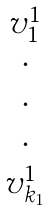<formula> <loc_0><loc_0><loc_500><loc_500>\begin{matrix} v _ { 1 } ^ { 1 } \\ \cdot \\ \cdot \\ \cdot \\ v _ { k _ { 1 } } ^ { 1 } \end{matrix}</formula> 